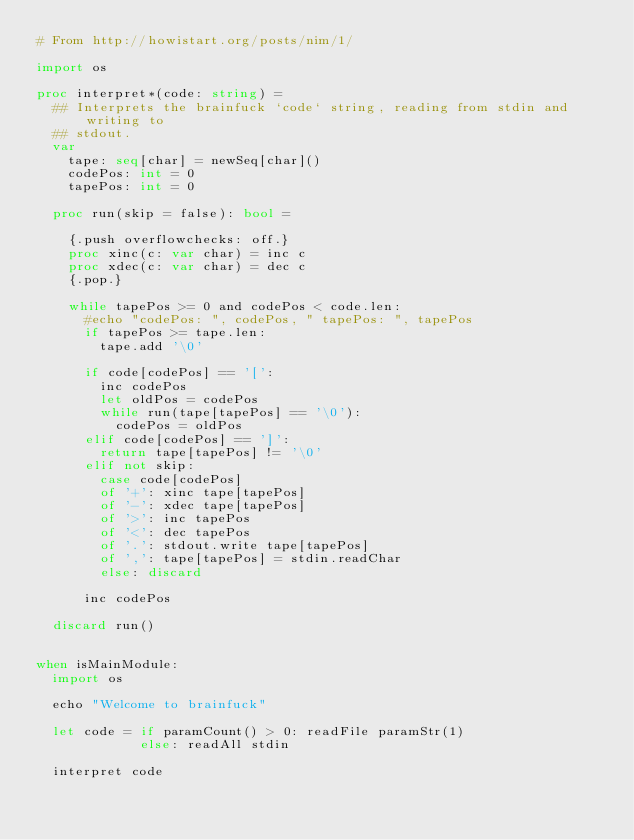<code> <loc_0><loc_0><loc_500><loc_500><_Nim_># From http://howistart.org/posts/nim/1/

import os

proc interpret*(code: string) = 
  ## Interprets the brainfuck `code` string, reading from stdin and writing to
  ## stdout.
  var
    tape: seq[char] = newSeq[char]()
    codePos: int = 0
    tapePos: int = 0

  proc run(skip = false): bool =
  
    {.push overflowchecks: off.}
    proc xinc(c: var char) = inc c
    proc xdec(c: var char) = dec c
    {.pop.}
  
    while tapePos >= 0 and codePos < code.len:
      #echo "codePos: ", codePos, " tapePos: ", tapePos
      if tapePos >= tape.len:
        tape.add '\0'

      if code[codePos] == '[':
        inc codePos
        let oldPos = codePos
        while run(tape[tapePos] == '\0'):
          codePos = oldPos
      elif code[codePos] == ']':
        return tape[tapePos] != '\0'
      elif not skip:
        case code[codePos]
        of '+': xinc tape[tapePos]
        of '-': xdec tape[tapePos]
        of '>': inc tapePos
        of '<': dec tapePos
        of '.': stdout.write tape[tapePos]
        of ',': tape[tapePos] = stdin.readChar
        else: discard

      inc codePos
 
  discard run()


when isMainModule:
  import os
  
  echo "Welcome to brainfuck"
 
  let code = if paramCount() > 0: readFile paramStr(1)
             else: readAll stdin

  interpret code
</code> 